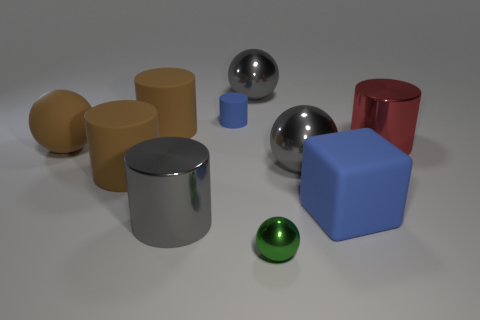Subtract all green metallic balls. How many balls are left? 3 Subtract 1 balls. How many balls are left? 3 Subtract all red cylinders. How many cylinders are left? 4 Subtract all blue cylinders. Subtract all green balls. How many cylinders are left? 4 Subtract 0 purple balls. How many objects are left? 10 Subtract all cubes. How many objects are left? 9 Subtract all tiny blue cylinders. Subtract all small green blocks. How many objects are left? 9 Add 7 small balls. How many small balls are left? 8 Add 7 tiny green balls. How many tiny green balls exist? 8 